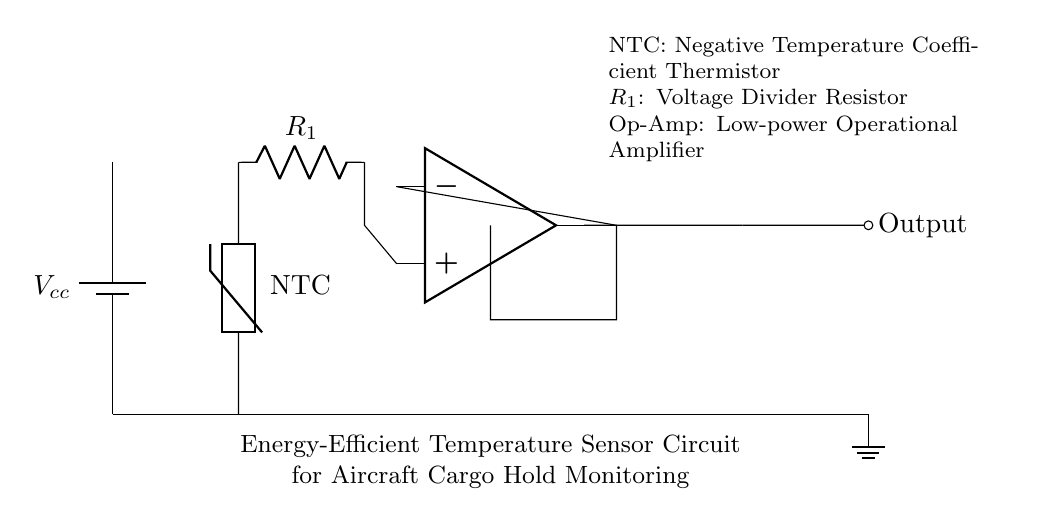What component is used for temperature sensing? The circuit uses a thermistor for temperature sensing. Specifically, it is a Negative Temperature Coefficient (NTC) thermistor which decreases resistance as temperature increases.
Answer: thermistor What is the function of the resistor in the circuit? The resistor, labeled R1, forms a voltage divider with the thermistor. Its purpose is to bias the thermistor output voltage to a usable level for the operational amplifier.
Answer: voltage divider What type of operational amplifier is used in this circuit? The operational amplifier used in this circuit is a low-power operational amplifier, which is important for efficient energy consumption in low power applications like this one.
Answer: low-power operational amplifier What does the output of the operational amplifier represent? The output of the operational amplifier represents a conditioned signal that indicates the temperature reading derived from the thermistor's resistance changes.
Answer: conditioned signal How does the temperature sensing mechanism work in this circuit? The temperature sensing mechanism works by varying the resistance of the thermistor in response to temperature changes, which alters the voltage at the operational amplifier input. By amplifying this voltage change, the output provides an accurate temperature indication.
Answer: varying resistance What is the power source of the circuit? The power source of the circuit is a battery, indicated by the battery symbol, providing a supply voltage labeled as Vcc.
Answer: battery What advantage does using an NTC thermistor provide in this application? An NTC thermistor provides higher sensitivity at lower temperatures, making it particularly suitable for detecting temperature variations in the aircraft cargo hold.
Answer: higher sensitivity 